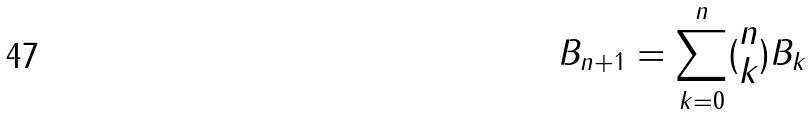Convert formula to latex. <formula><loc_0><loc_0><loc_500><loc_500>B _ { n + 1 } = \sum _ { k = 0 } ^ { n } ( \begin{matrix} n \\ k \end{matrix} ) B _ { k }</formula> 